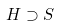<formula> <loc_0><loc_0><loc_500><loc_500>H \supset S</formula> 